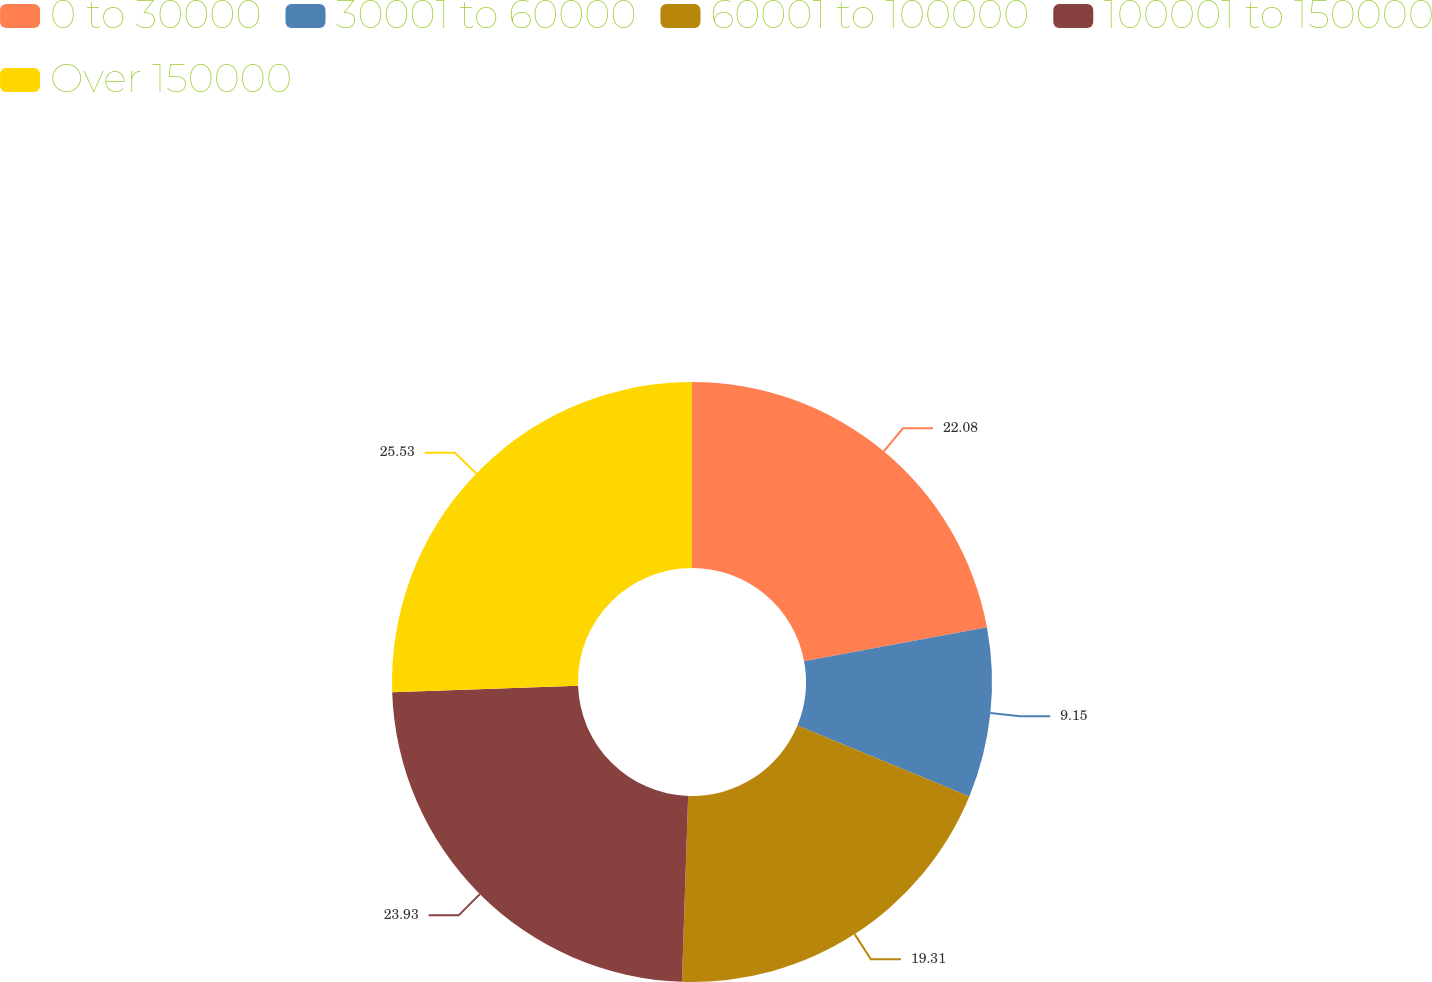Convert chart to OTSL. <chart><loc_0><loc_0><loc_500><loc_500><pie_chart><fcel>0 to 30000<fcel>30001 to 60000<fcel>60001 to 100000<fcel>100001 to 150000<fcel>Over 150000<nl><fcel>22.08%<fcel>9.15%<fcel>19.31%<fcel>23.93%<fcel>25.54%<nl></chart> 